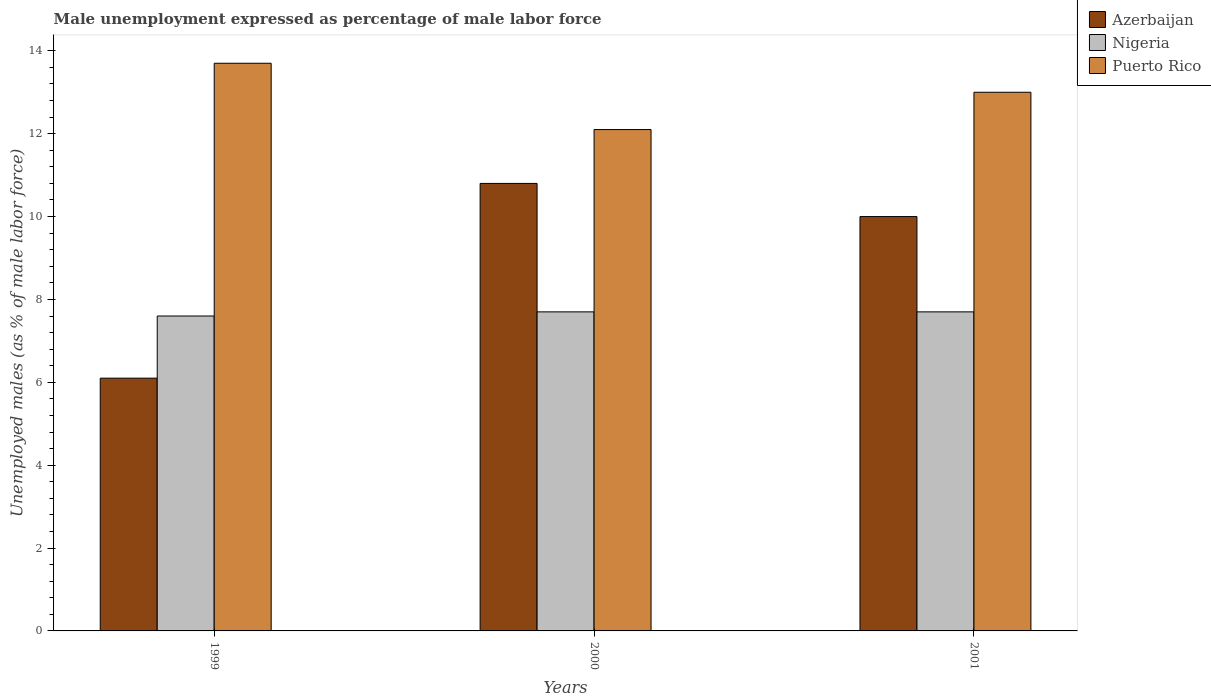How many different coloured bars are there?
Offer a very short reply. 3. Are the number of bars per tick equal to the number of legend labels?
Provide a succinct answer. Yes. Are the number of bars on each tick of the X-axis equal?
Your answer should be compact. Yes. How many bars are there on the 1st tick from the right?
Offer a terse response. 3. What is the label of the 1st group of bars from the left?
Your answer should be very brief. 1999. In how many cases, is the number of bars for a given year not equal to the number of legend labels?
Provide a short and direct response. 0. What is the unemployment in males in in Nigeria in 1999?
Your answer should be very brief. 7.6. Across all years, what is the maximum unemployment in males in in Puerto Rico?
Your answer should be very brief. 13.7. Across all years, what is the minimum unemployment in males in in Nigeria?
Provide a succinct answer. 7.6. In which year was the unemployment in males in in Azerbaijan maximum?
Keep it short and to the point. 2000. What is the total unemployment in males in in Puerto Rico in the graph?
Ensure brevity in your answer.  38.8. What is the difference between the unemployment in males in in Azerbaijan in 1999 and that in 2001?
Keep it short and to the point. -3.9. What is the difference between the unemployment in males in in Nigeria in 2001 and the unemployment in males in in Puerto Rico in 1999?
Make the answer very short. -6. What is the average unemployment in males in in Azerbaijan per year?
Keep it short and to the point. 8.97. In the year 1999, what is the difference between the unemployment in males in in Nigeria and unemployment in males in in Puerto Rico?
Offer a very short reply. -6.1. In how many years, is the unemployment in males in in Puerto Rico greater than 2.8 %?
Ensure brevity in your answer.  3. What is the ratio of the unemployment in males in in Azerbaijan in 1999 to that in 2001?
Your answer should be very brief. 0.61. What is the difference between the highest and the lowest unemployment in males in in Nigeria?
Keep it short and to the point. 0.1. Is the sum of the unemployment in males in in Puerto Rico in 2000 and 2001 greater than the maximum unemployment in males in in Nigeria across all years?
Keep it short and to the point. Yes. What does the 2nd bar from the left in 2001 represents?
Make the answer very short. Nigeria. What does the 2nd bar from the right in 2000 represents?
Your answer should be compact. Nigeria. How many bars are there?
Your answer should be very brief. 9. Are the values on the major ticks of Y-axis written in scientific E-notation?
Provide a short and direct response. No. Does the graph contain grids?
Offer a terse response. No. Where does the legend appear in the graph?
Offer a terse response. Top right. What is the title of the graph?
Your answer should be very brief. Male unemployment expressed as percentage of male labor force. What is the label or title of the Y-axis?
Your answer should be very brief. Unemployed males (as % of male labor force). What is the Unemployed males (as % of male labor force) in Azerbaijan in 1999?
Ensure brevity in your answer.  6.1. What is the Unemployed males (as % of male labor force) in Nigeria in 1999?
Your response must be concise. 7.6. What is the Unemployed males (as % of male labor force) in Puerto Rico in 1999?
Keep it short and to the point. 13.7. What is the Unemployed males (as % of male labor force) of Azerbaijan in 2000?
Make the answer very short. 10.8. What is the Unemployed males (as % of male labor force) in Nigeria in 2000?
Provide a short and direct response. 7.7. What is the Unemployed males (as % of male labor force) of Puerto Rico in 2000?
Provide a succinct answer. 12.1. What is the Unemployed males (as % of male labor force) in Nigeria in 2001?
Ensure brevity in your answer.  7.7. Across all years, what is the maximum Unemployed males (as % of male labor force) of Azerbaijan?
Provide a short and direct response. 10.8. Across all years, what is the maximum Unemployed males (as % of male labor force) of Nigeria?
Provide a short and direct response. 7.7. Across all years, what is the maximum Unemployed males (as % of male labor force) in Puerto Rico?
Offer a terse response. 13.7. Across all years, what is the minimum Unemployed males (as % of male labor force) in Azerbaijan?
Offer a terse response. 6.1. Across all years, what is the minimum Unemployed males (as % of male labor force) of Nigeria?
Make the answer very short. 7.6. Across all years, what is the minimum Unemployed males (as % of male labor force) of Puerto Rico?
Your response must be concise. 12.1. What is the total Unemployed males (as % of male labor force) in Azerbaijan in the graph?
Offer a terse response. 26.9. What is the total Unemployed males (as % of male labor force) in Nigeria in the graph?
Your answer should be very brief. 23. What is the total Unemployed males (as % of male labor force) in Puerto Rico in the graph?
Your response must be concise. 38.8. What is the difference between the Unemployed males (as % of male labor force) of Azerbaijan in 1999 and that in 2000?
Keep it short and to the point. -4.7. What is the difference between the Unemployed males (as % of male labor force) of Azerbaijan in 1999 and that in 2001?
Provide a succinct answer. -3.9. What is the difference between the Unemployed males (as % of male labor force) of Azerbaijan in 2000 and that in 2001?
Ensure brevity in your answer.  0.8. What is the difference between the Unemployed males (as % of male labor force) of Nigeria in 2000 and that in 2001?
Offer a very short reply. 0. What is the difference between the Unemployed males (as % of male labor force) of Puerto Rico in 2000 and that in 2001?
Provide a short and direct response. -0.9. What is the difference between the Unemployed males (as % of male labor force) of Azerbaijan in 1999 and the Unemployed males (as % of male labor force) of Puerto Rico in 2000?
Provide a short and direct response. -6. What is the difference between the Unemployed males (as % of male labor force) in Nigeria in 1999 and the Unemployed males (as % of male labor force) in Puerto Rico in 2000?
Your answer should be very brief. -4.5. What is the difference between the Unemployed males (as % of male labor force) of Nigeria in 1999 and the Unemployed males (as % of male labor force) of Puerto Rico in 2001?
Offer a very short reply. -5.4. What is the difference between the Unemployed males (as % of male labor force) in Azerbaijan in 2000 and the Unemployed males (as % of male labor force) in Nigeria in 2001?
Ensure brevity in your answer.  3.1. What is the average Unemployed males (as % of male labor force) in Azerbaijan per year?
Your answer should be compact. 8.97. What is the average Unemployed males (as % of male labor force) in Nigeria per year?
Your answer should be compact. 7.67. What is the average Unemployed males (as % of male labor force) of Puerto Rico per year?
Make the answer very short. 12.93. In the year 1999, what is the difference between the Unemployed males (as % of male labor force) in Azerbaijan and Unemployed males (as % of male labor force) in Nigeria?
Ensure brevity in your answer.  -1.5. In the year 2000, what is the difference between the Unemployed males (as % of male labor force) in Nigeria and Unemployed males (as % of male labor force) in Puerto Rico?
Provide a succinct answer. -4.4. In the year 2001, what is the difference between the Unemployed males (as % of male labor force) of Azerbaijan and Unemployed males (as % of male labor force) of Puerto Rico?
Keep it short and to the point. -3. What is the ratio of the Unemployed males (as % of male labor force) in Azerbaijan in 1999 to that in 2000?
Your answer should be compact. 0.56. What is the ratio of the Unemployed males (as % of male labor force) of Puerto Rico in 1999 to that in 2000?
Offer a terse response. 1.13. What is the ratio of the Unemployed males (as % of male labor force) in Azerbaijan in 1999 to that in 2001?
Provide a succinct answer. 0.61. What is the ratio of the Unemployed males (as % of male labor force) of Nigeria in 1999 to that in 2001?
Offer a very short reply. 0.99. What is the ratio of the Unemployed males (as % of male labor force) of Puerto Rico in 1999 to that in 2001?
Make the answer very short. 1.05. What is the ratio of the Unemployed males (as % of male labor force) of Azerbaijan in 2000 to that in 2001?
Provide a short and direct response. 1.08. What is the ratio of the Unemployed males (as % of male labor force) in Puerto Rico in 2000 to that in 2001?
Provide a succinct answer. 0.93. What is the difference between the highest and the second highest Unemployed males (as % of male labor force) of Azerbaijan?
Provide a succinct answer. 0.8. What is the difference between the highest and the second highest Unemployed males (as % of male labor force) of Nigeria?
Offer a terse response. 0. What is the difference between the highest and the lowest Unemployed males (as % of male labor force) in Azerbaijan?
Provide a succinct answer. 4.7. What is the difference between the highest and the lowest Unemployed males (as % of male labor force) of Nigeria?
Give a very brief answer. 0.1. 